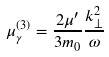Convert formula to latex. <formula><loc_0><loc_0><loc_500><loc_500>\mu _ { \gamma } ^ { ( 3 ) } = \frac { 2 \mu ^ { \prime } } { 3 m _ { 0 } } \frac { k _ { \perp } ^ { 2 } } { \omega }</formula> 